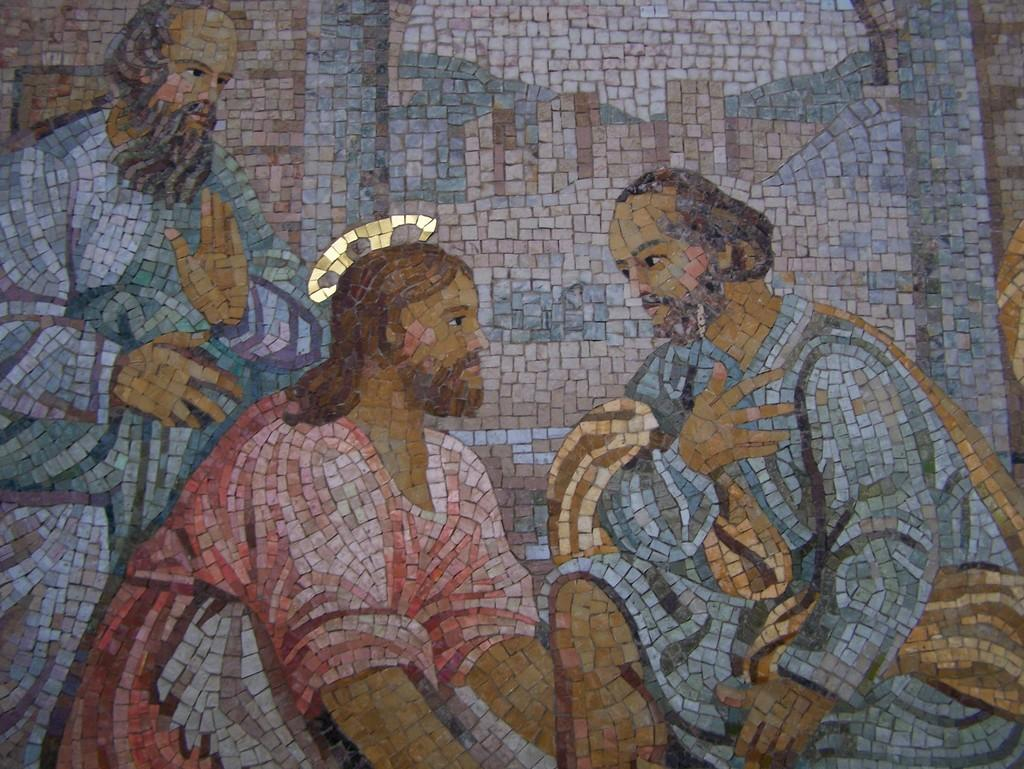What is depicted on the wall in the image? There are pictures of persons on the wall. What material is used to create the pictures? The pictures are made with marble chips. What type of wrist accessory is visible in the image? There is no wrist accessory present in the image. Is there a bomb or alarm visible in the image? No, there is no bomb or alarm present in the image. 